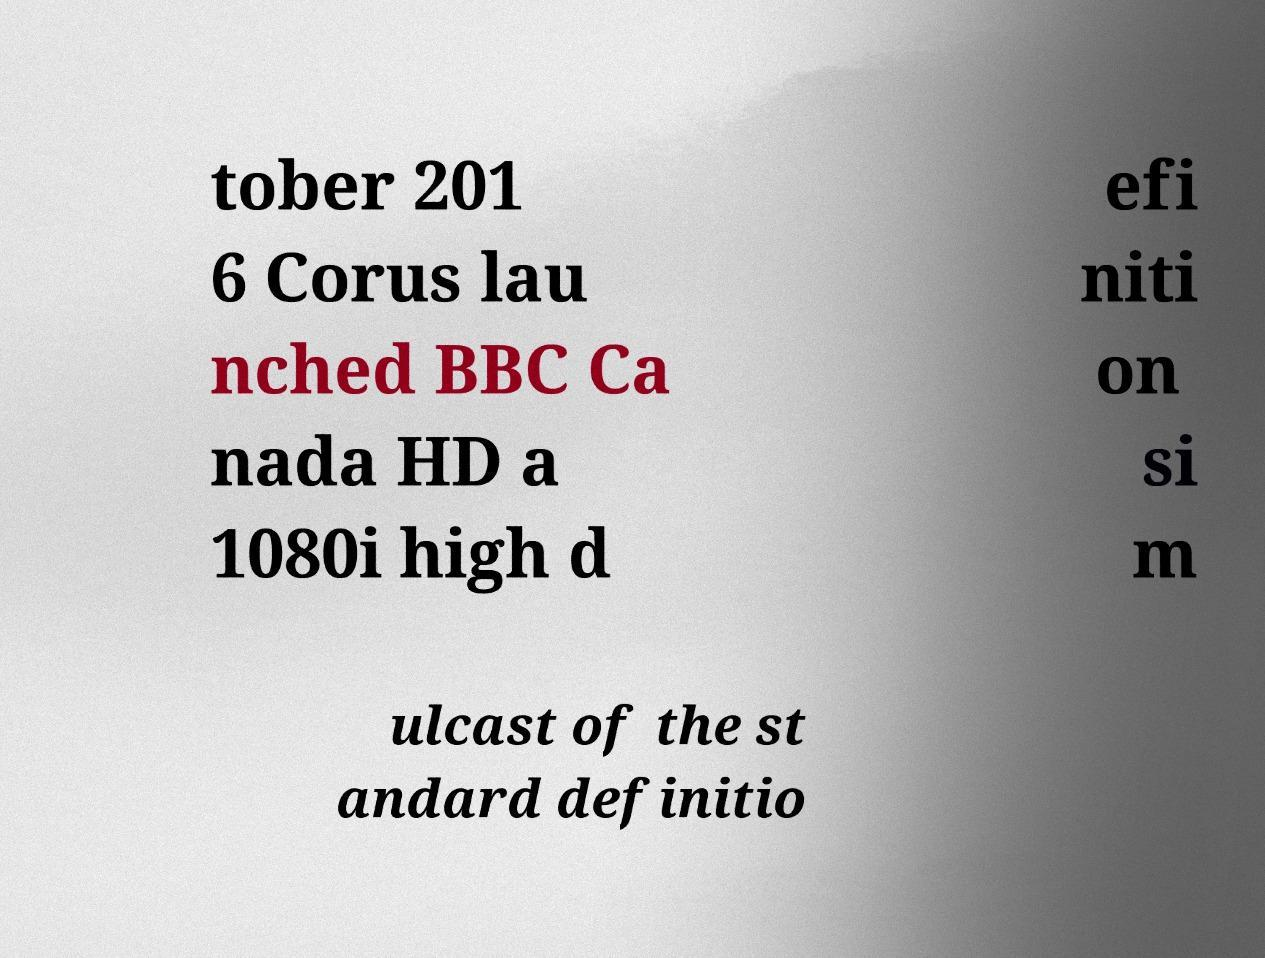Could you assist in decoding the text presented in this image and type it out clearly? tober 201 6 Corus lau nched BBC Ca nada HD a 1080i high d efi niti on si m ulcast of the st andard definitio 